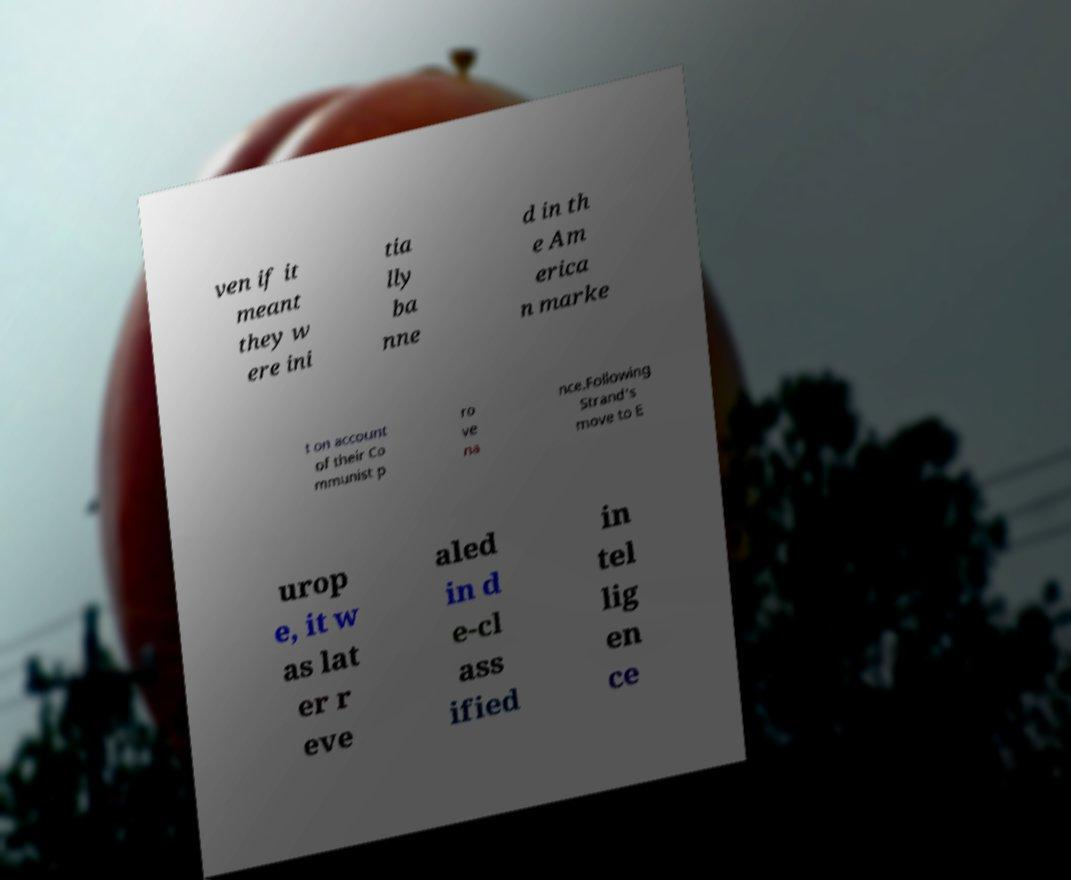Can you accurately transcribe the text from the provided image for me? ven if it meant they w ere ini tia lly ba nne d in th e Am erica n marke t on account of their Co mmunist p ro ve na nce.Following Strand's move to E urop e, it w as lat er r eve aled in d e-cl ass ified in tel lig en ce 